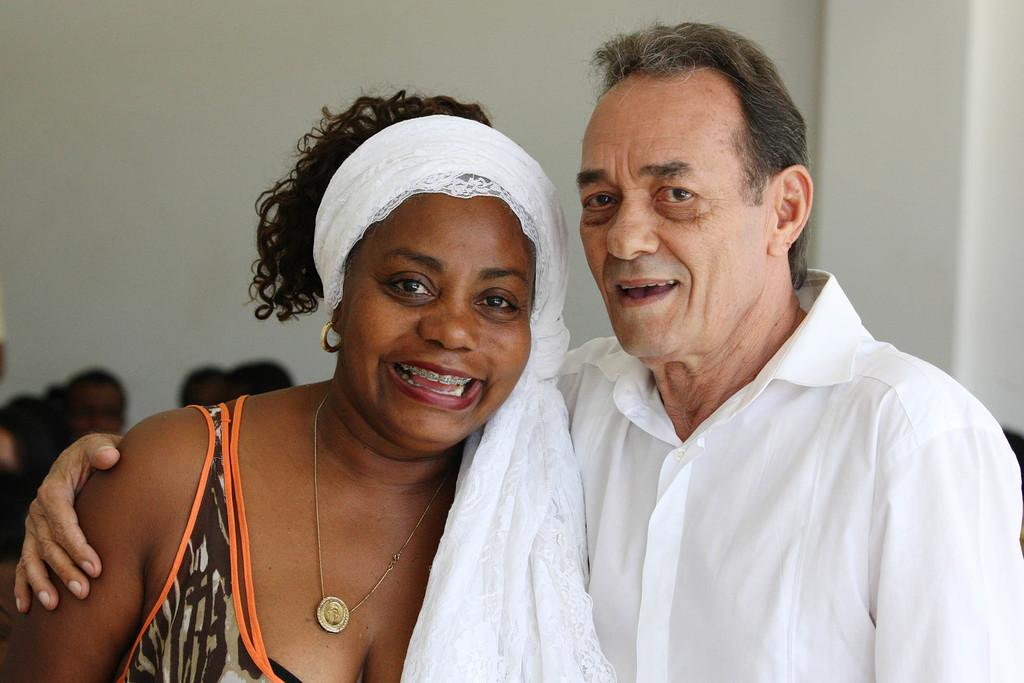Who are the main subjects in the image? There is a lady and a man in the center of the image. Are there any other people visible in the image? Yes, there are people on the left side of the image. What can be seen in the background of the image? There is a wall in the background of the image. What type of art is the coach teaching in the image? There is no coach or art lesson present in the image. 